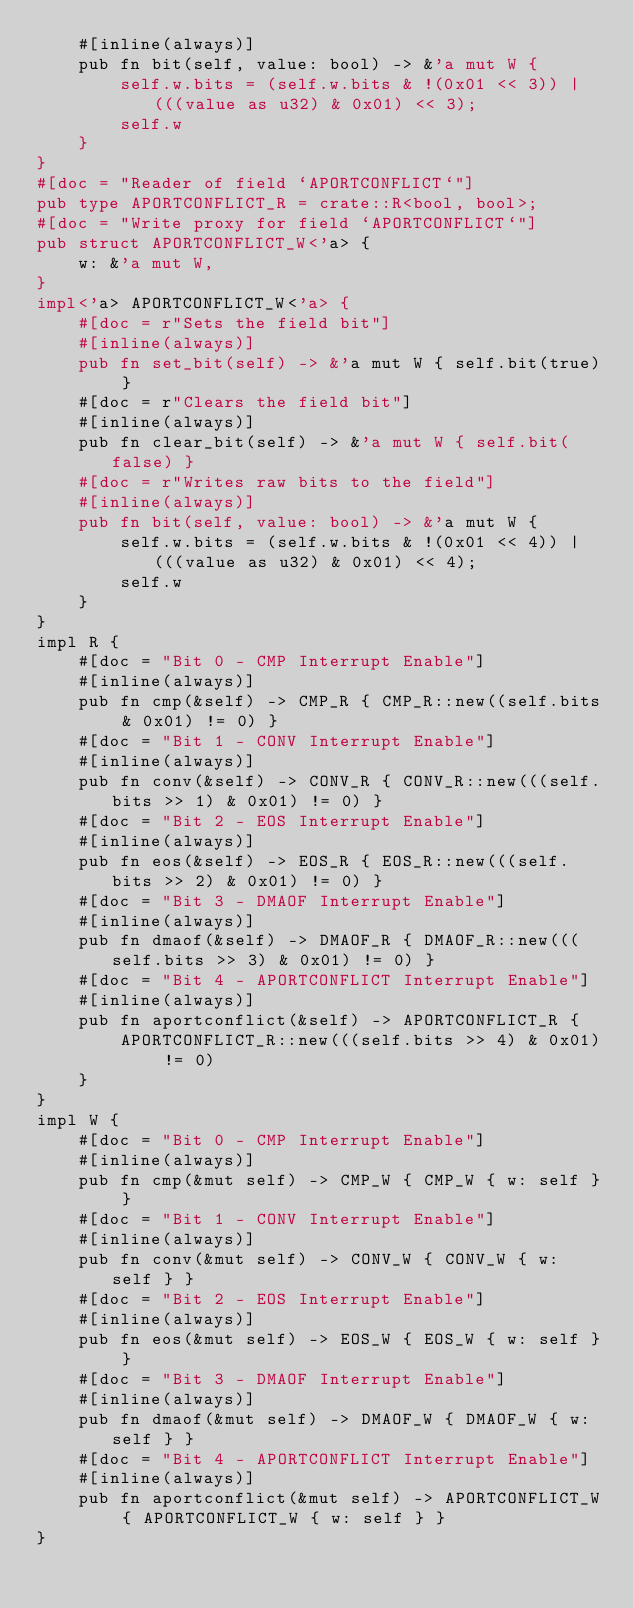<code> <loc_0><loc_0><loc_500><loc_500><_Rust_>    #[inline(always)]
    pub fn bit(self, value: bool) -> &'a mut W {
        self.w.bits = (self.w.bits & !(0x01 << 3)) | (((value as u32) & 0x01) << 3);
        self.w
    }
}
#[doc = "Reader of field `APORTCONFLICT`"]
pub type APORTCONFLICT_R = crate::R<bool, bool>;
#[doc = "Write proxy for field `APORTCONFLICT`"]
pub struct APORTCONFLICT_W<'a> {
    w: &'a mut W,
}
impl<'a> APORTCONFLICT_W<'a> {
    #[doc = r"Sets the field bit"]
    #[inline(always)]
    pub fn set_bit(self) -> &'a mut W { self.bit(true) }
    #[doc = r"Clears the field bit"]
    #[inline(always)]
    pub fn clear_bit(self) -> &'a mut W { self.bit(false) }
    #[doc = r"Writes raw bits to the field"]
    #[inline(always)]
    pub fn bit(self, value: bool) -> &'a mut W {
        self.w.bits = (self.w.bits & !(0x01 << 4)) | (((value as u32) & 0x01) << 4);
        self.w
    }
}
impl R {
    #[doc = "Bit 0 - CMP Interrupt Enable"]
    #[inline(always)]
    pub fn cmp(&self) -> CMP_R { CMP_R::new((self.bits & 0x01) != 0) }
    #[doc = "Bit 1 - CONV Interrupt Enable"]
    #[inline(always)]
    pub fn conv(&self) -> CONV_R { CONV_R::new(((self.bits >> 1) & 0x01) != 0) }
    #[doc = "Bit 2 - EOS Interrupt Enable"]
    #[inline(always)]
    pub fn eos(&self) -> EOS_R { EOS_R::new(((self.bits >> 2) & 0x01) != 0) }
    #[doc = "Bit 3 - DMAOF Interrupt Enable"]
    #[inline(always)]
    pub fn dmaof(&self) -> DMAOF_R { DMAOF_R::new(((self.bits >> 3) & 0x01) != 0) }
    #[doc = "Bit 4 - APORTCONFLICT Interrupt Enable"]
    #[inline(always)]
    pub fn aportconflict(&self) -> APORTCONFLICT_R {
        APORTCONFLICT_R::new(((self.bits >> 4) & 0x01) != 0)
    }
}
impl W {
    #[doc = "Bit 0 - CMP Interrupt Enable"]
    #[inline(always)]
    pub fn cmp(&mut self) -> CMP_W { CMP_W { w: self } }
    #[doc = "Bit 1 - CONV Interrupt Enable"]
    #[inline(always)]
    pub fn conv(&mut self) -> CONV_W { CONV_W { w: self } }
    #[doc = "Bit 2 - EOS Interrupt Enable"]
    #[inline(always)]
    pub fn eos(&mut self) -> EOS_W { EOS_W { w: self } }
    #[doc = "Bit 3 - DMAOF Interrupt Enable"]
    #[inline(always)]
    pub fn dmaof(&mut self) -> DMAOF_W { DMAOF_W { w: self } }
    #[doc = "Bit 4 - APORTCONFLICT Interrupt Enable"]
    #[inline(always)]
    pub fn aportconflict(&mut self) -> APORTCONFLICT_W { APORTCONFLICT_W { w: self } }
}
</code> 